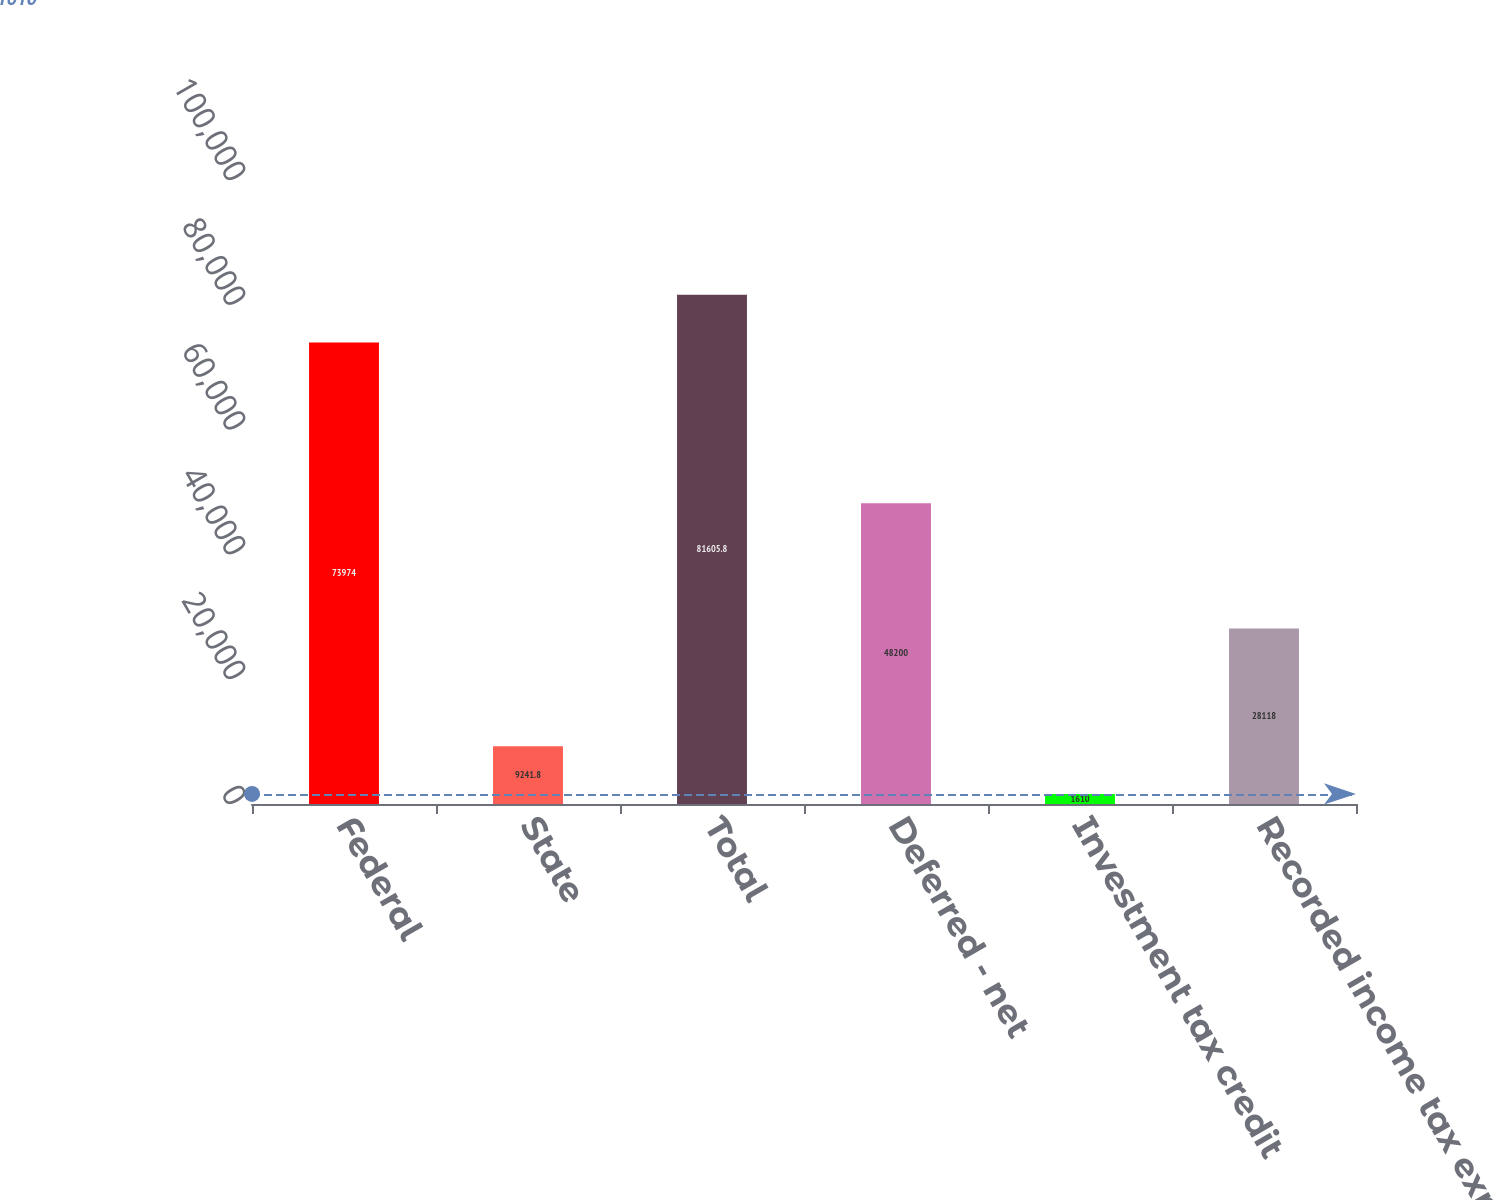Convert chart. <chart><loc_0><loc_0><loc_500><loc_500><bar_chart><fcel>Federal<fcel>State<fcel>Total<fcel>Deferred - net<fcel>Investment tax credit<fcel>Recorded income tax expense<nl><fcel>73974<fcel>9241.8<fcel>81605.8<fcel>48200<fcel>1610<fcel>28118<nl></chart> 